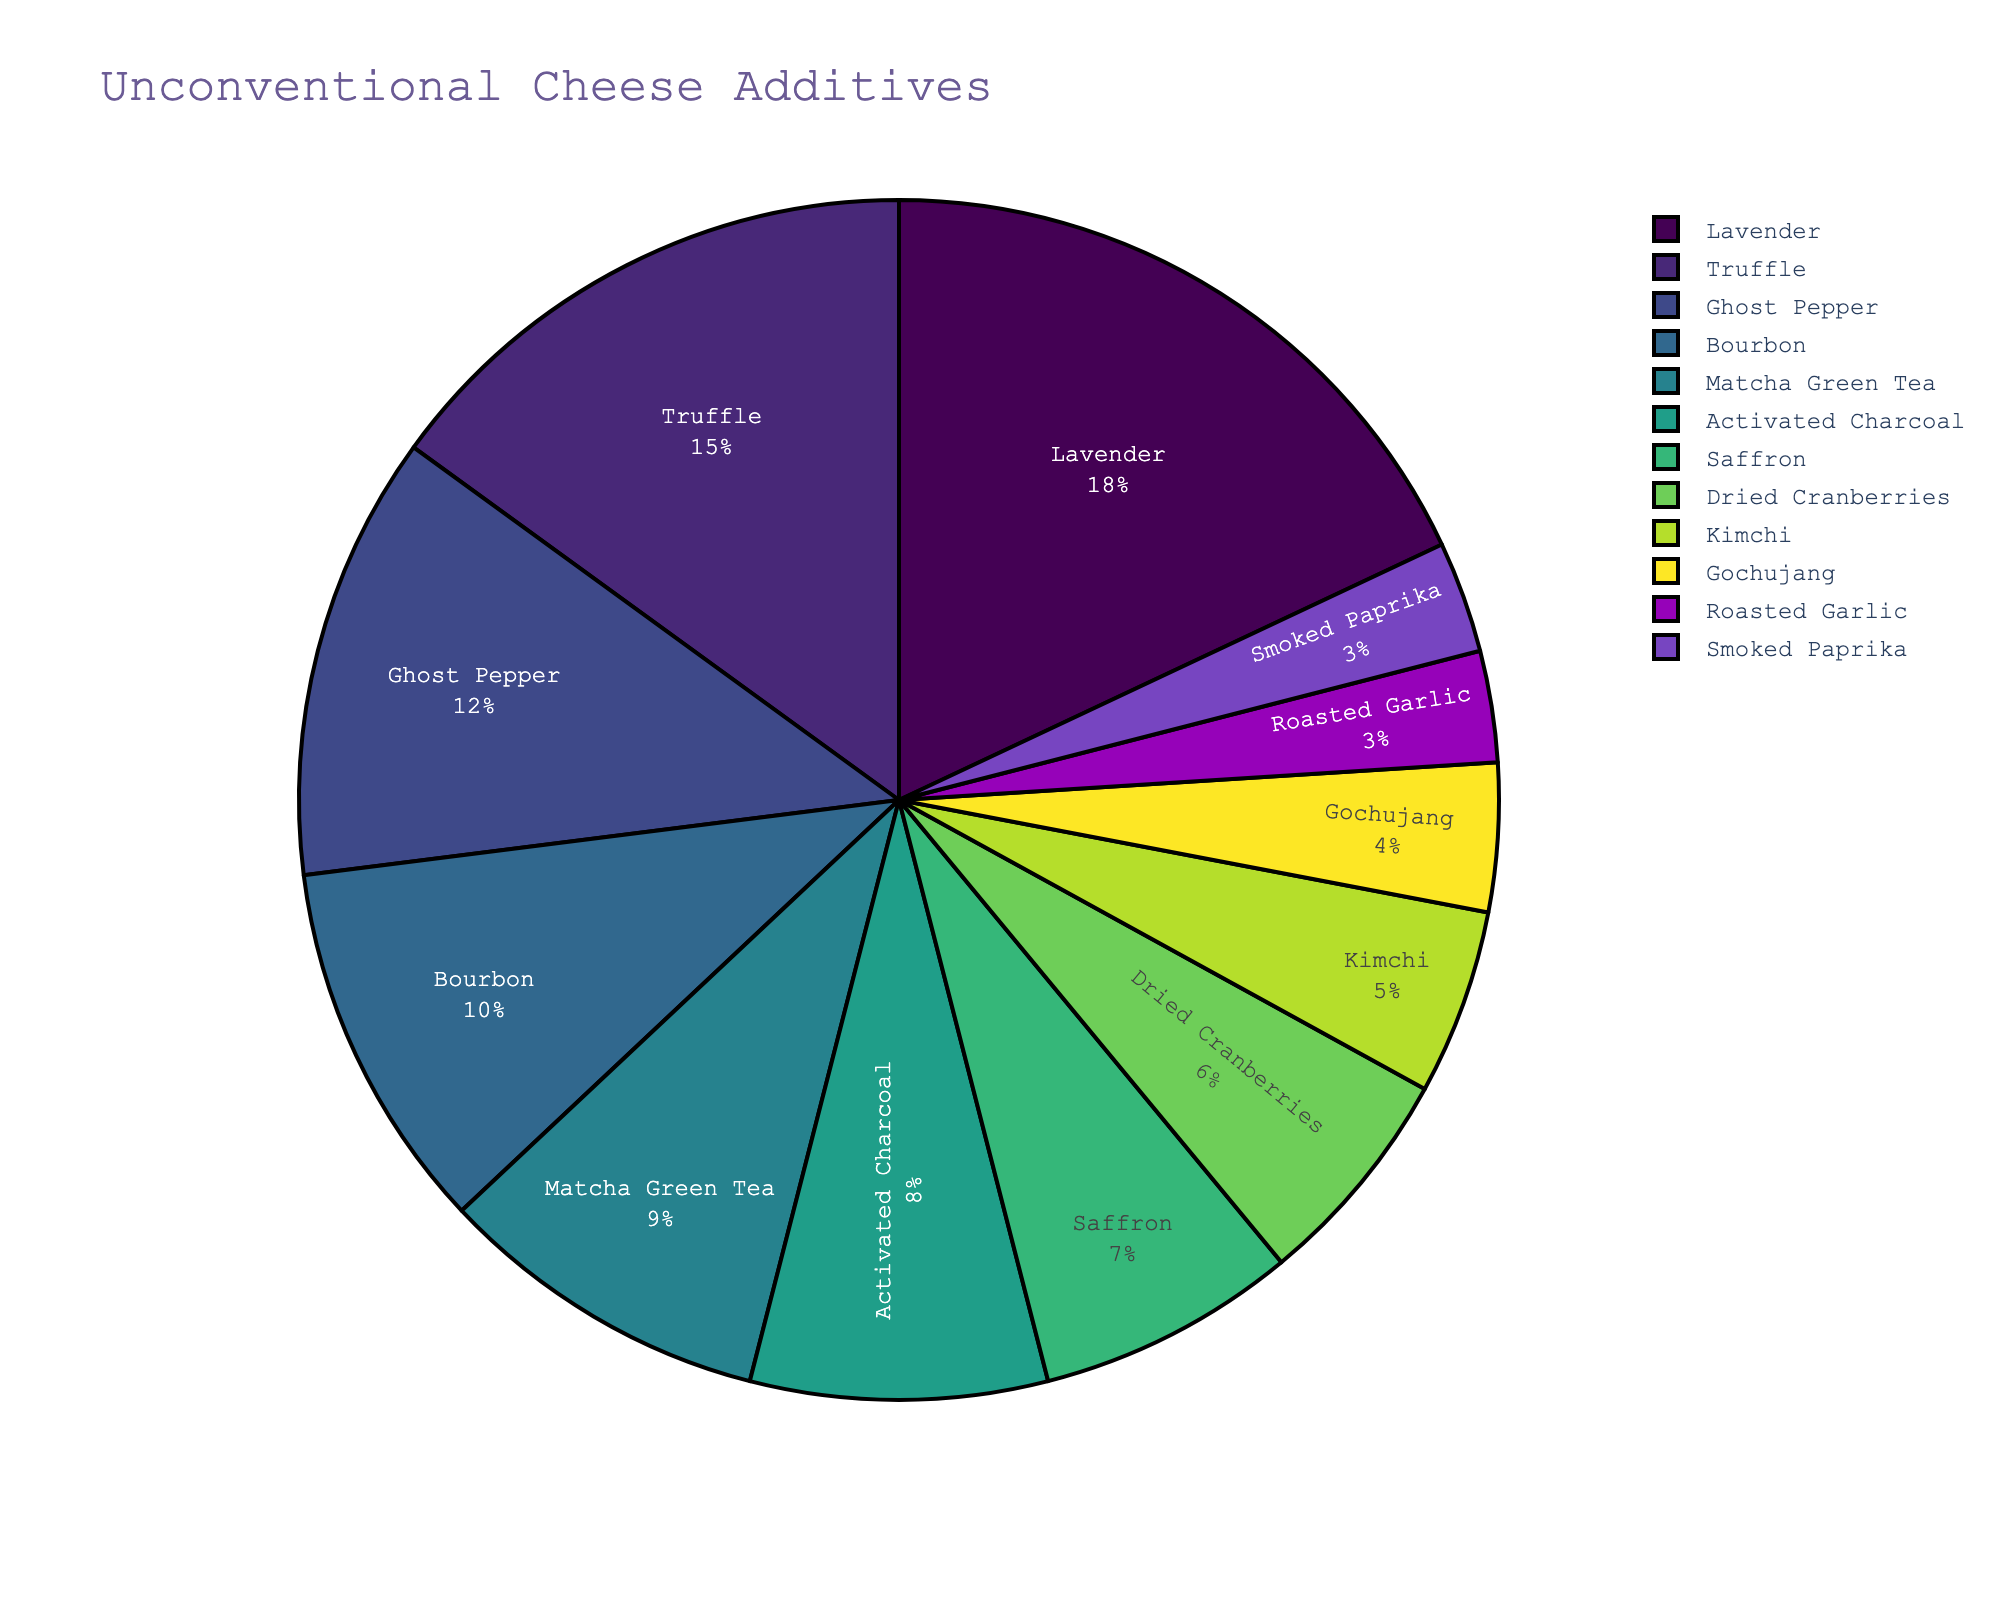What percentage of the pie chart is made up by the top three additives? First, identify the top three percentages: Lavender (18%), Truffle (15%), and Ghost Pepper (12%). Then, sum these percentages: 18% + 15% + 12% = 45%.
Answer: 45% Which additive has the smallest percentage? Identify the smallest percentage from the chart: Roasted Garlic and Smoked Paprika both have the smallest percentage at 3%.
Answer: Roasted Garlic and Smoked Paprika Which additive is more prevalent, Bourbon or Matcha Green Tea? Compare the percentages of Bourbon (10%) and Matcha Green Tea (9%). Bourbon has a higher percentage than Matcha Green Tea.
Answer: Bourbon How much more prevalent is Lavender compared to Kimchi? Find the percentage for Lavender (18%) and Kimchi (5%), then subtract the two: 18% - 5% = 13%.
Answer: 13% What is the total percentage of additives that are less prevalent than Activated Charcoal? Identify additives less prevalent than Activated Charcoal (8%): Saffron (7%), Dried Cranberries (6%), Kimchi (5%), Gochujang (4%), Roasted Garlic (3%), Smoked Paprika (3%). Sum these percentages: 7% + 6% + 5% + 4% + 3% + 3% = 28%.
Answer: 28% Which two additives combined account for 15% of the pie chart? Identify additives with percentages that sum to 15%. Dried Cranberries (6%) and Kimchi (5%) sum to 11%, and adding Gochujang (4%) makes a total of 15%.
Answer: Dried Cranberries and Gochujang List the top five additives in the chart. Identify the top five percentages: Lavender (18%), Truffle (15%), Ghost Pepper (12%), Bourbon (10%), and Matcha Green Tea (9%).
Answer: Lavender, Truffle, Ghost Pepper, Bourbon, Matcha Green Tea What percentage of the chart is made up of herb-based additives? Identify herb-based additives: Lavender (18%) and Truffle (15%). Sum these percentages: 18% + 15% = 33%.
Answer: 33% Which is more prevalent, the sum of percentages for the three least prevalent additives or Lavender? Identify the three least prevalent additives: Roasted Garlic (3%), Smoked Paprika (3%), Gochujang (4%). Sum these percentages: 3% + 3% + 4% = 10%. Lavender is more prevalent with 18%.
Answer: Lavender How many additives have a percentage greater than or equal to 10%? Identify additives where the percentage is greater than or equal to 10%: Lavender (18%), Truffle (15%), Ghost Pepper (12%), Bourbon (10%). There are 4 such additives.
Answer: 4 